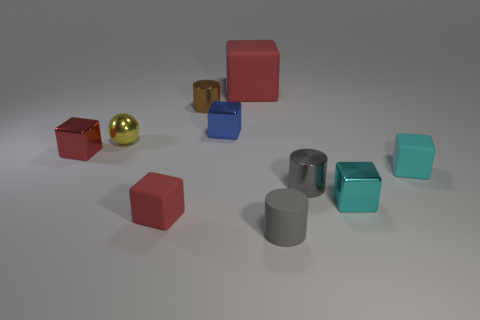How many other objects are the same shape as the tiny brown thing?
Give a very brief answer. 2. What number of yellow things are either spheres or cylinders?
Offer a very short reply. 1. What is the color of the cylinder that is made of the same material as the big red cube?
Make the answer very short. Gray. Does the red thing that is behind the yellow shiny thing have the same material as the tiny cyan cube to the right of the cyan metallic block?
Provide a succinct answer. Yes. What is the small red block in front of the small red shiny block made of?
Keep it short and to the point. Rubber. There is a tiny rubber object on the left side of the large red block; does it have the same shape as the tiny gray matte thing that is to the right of the small red metallic cube?
Give a very brief answer. No. What material is the tiny thing that is the same color as the matte cylinder?
Offer a very short reply. Metal. Is there a tiny purple shiny cube?
Ensure brevity in your answer.  No. There is a big red object that is the same shape as the blue metallic thing; what is its material?
Offer a very short reply. Rubber. Are there any shiny things in front of the yellow ball?
Ensure brevity in your answer.  Yes. 